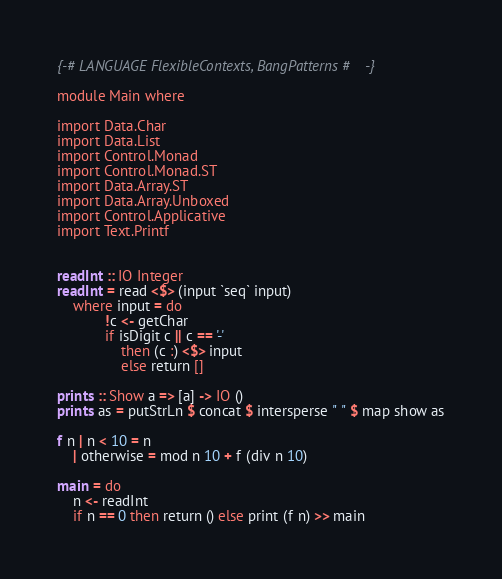<code> <loc_0><loc_0><loc_500><loc_500><_Haskell_>{-# LANGUAGE FlexibleContexts, BangPatterns #-}

module Main where

import Data.Char
import Data.List
import Control.Monad
import Control.Monad.ST
import Data.Array.ST
import Data.Array.Unboxed
import Control.Applicative
import Text.Printf


readInt :: IO Integer
readInt = read <$> (input `seq` input)
    where input = do
            !c <- getChar
            if isDigit c || c == '-'
                then (c :) <$> input
                else return []

prints :: Show a => [a] -> IO ()
prints as = putStrLn $ concat $ intersperse " " $ map show as

f n | n < 10 = n
    | otherwise = mod n 10 + f (div n 10)

main = do
    n <- readInt
    if n == 0 then return () else print (f n) >> main
</code> 